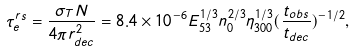Convert formula to latex. <formula><loc_0><loc_0><loc_500><loc_500>\tau _ { e } ^ { r s } = \frac { \sigma _ { T } { N } } { 4 \pi { r _ { d e c } ^ { 2 } } } = 8 . 4 \times 1 0 ^ { - 6 } { E _ { 5 3 } ^ { 1 / 3 } } { n _ { 0 } ^ { 2 / 3 } } { \eta _ { 3 0 0 } ^ { 1 / 3 } } ( \frac { t _ { o b s } } { t _ { d e c } } ) ^ { - 1 / 2 } ,</formula> 